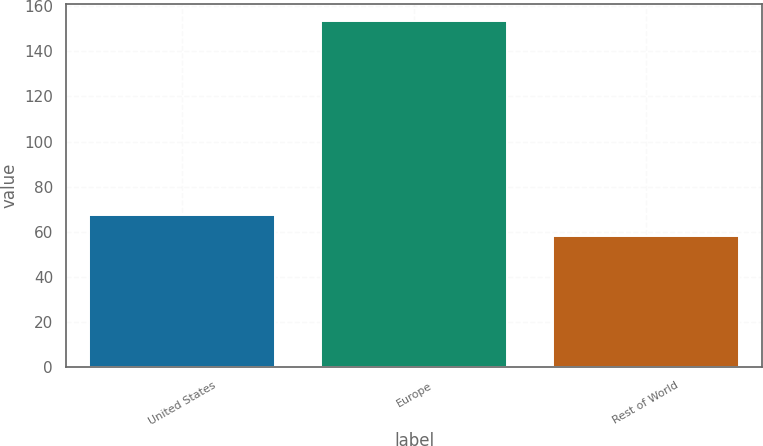Convert chart to OTSL. <chart><loc_0><loc_0><loc_500><loc_500><bar_chart><fcel>United States<fcel>Europe<fcel>Rest of World<nl><fcel>67.55<fcel>153.5<fcel>58<nl></chart> 